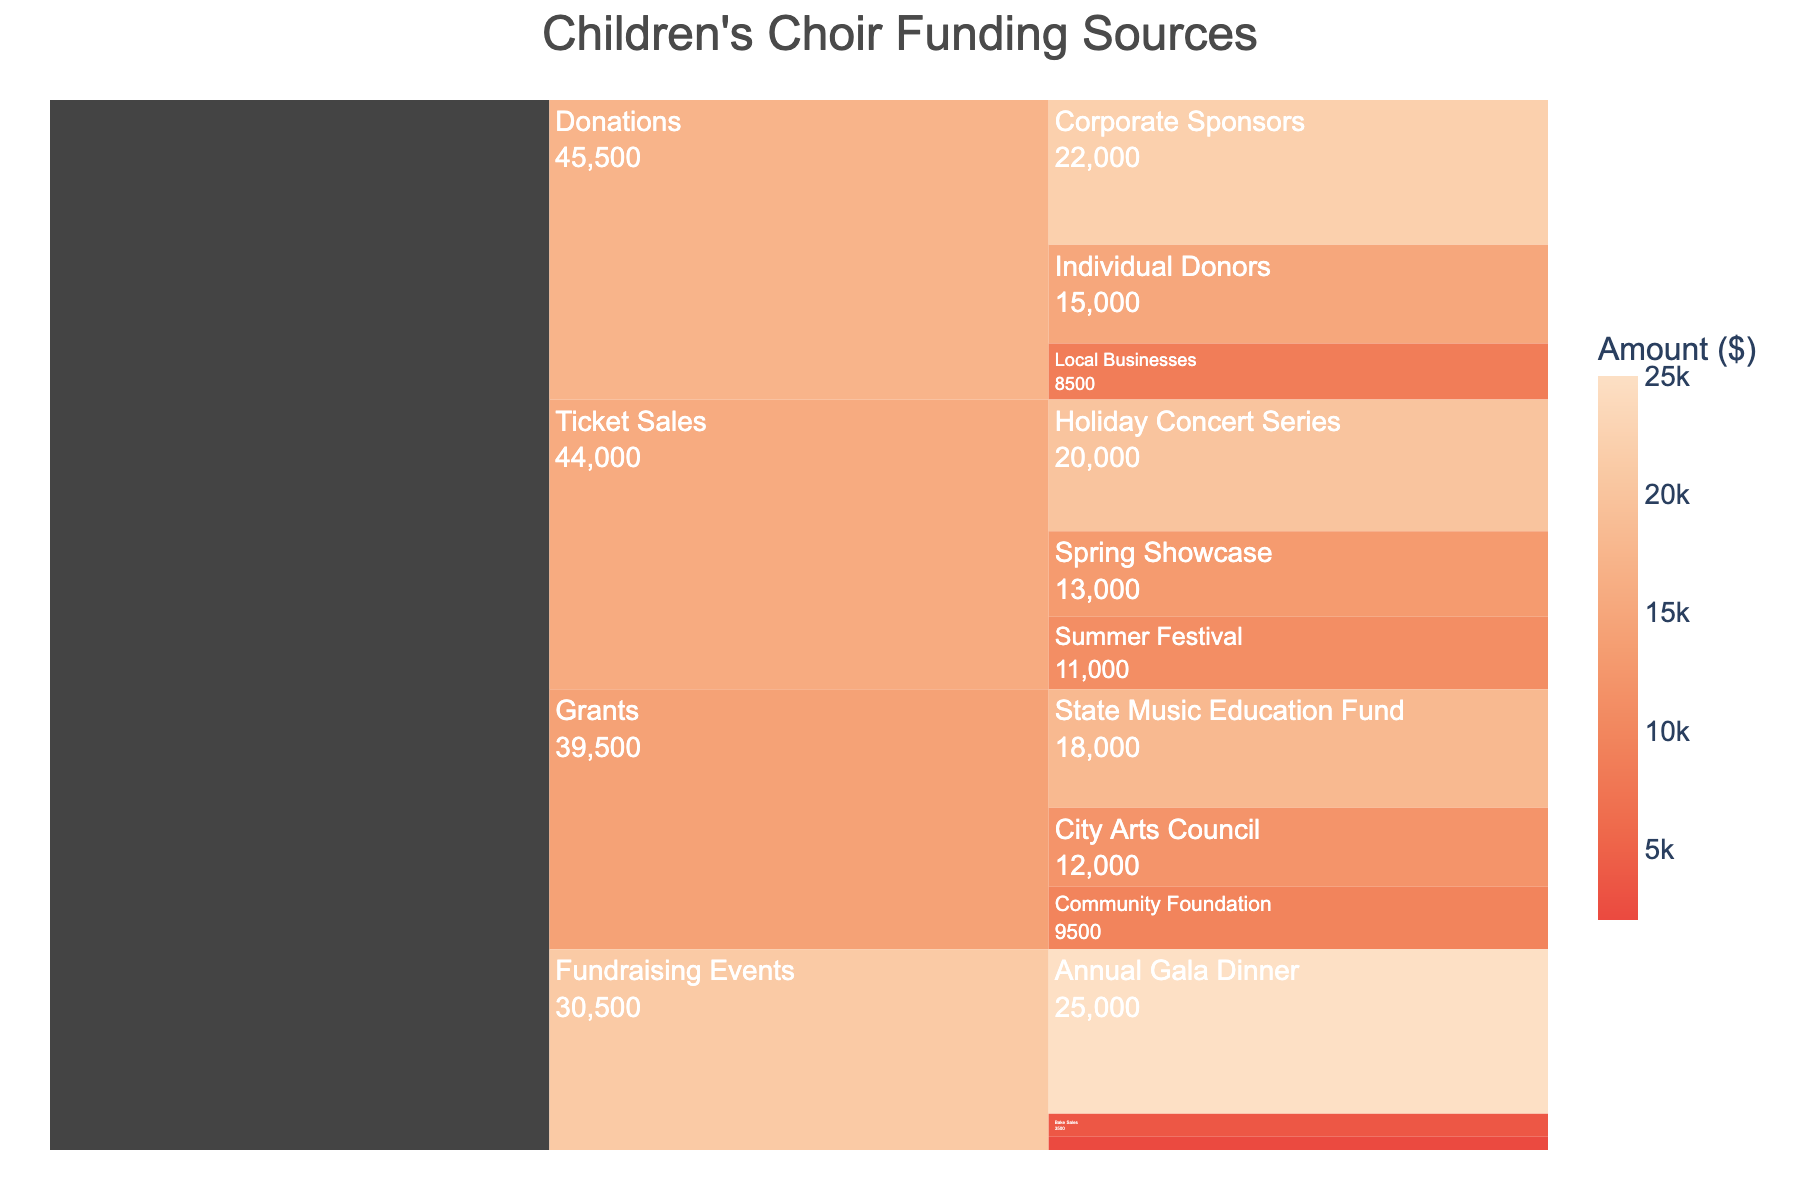What's the title of the chart? The title is usually displayed prominently at the top of a chart.
Answer: Children's Choir Funding Sources Which funding category has the highest total amount? To find the highest total amount, sum up the amounts for each category and compare them. The category with the highest total amount will be the answer.
Answer: Fundraising Events What is the total amount of funding from Donations? Add up the amounts from all the subcategories under Donations: 15000 (Individual Donors) + 22000 (Corporate Sponsors) + 8500 (Local Businesses).
Answer: 45500 What is the difference in the total amount between Ticket Sales and Grants? First, find the total for Ticket Sales (20000 + 13000 + 11000 = 44000) and for Grants (12000 + 18000 + 9500 = 39500). Then, subtract the total for Grants from Ticket Sales: 44000 - 39500.
Answer: 4500 Which subcategory under Fundraising Events contributes the most? By comparing the amounts in the subcategories under Fundraising Events, you can see which one has the highest value.
Answer: Annual Gala Dinner What is the color associated with the highest amount on the color scale? The highest amount is normally indicated by the color at the extreme end of the continuous color scale provided.
Answer: Dark Peach Which subcategory has the smallest amount? By identifying and comparing the amounts in all subcategories in the chart, the smallest value can be found.
Answer: Car Wash How much more funding does Individual Donors contribute compared to Local Businesses? Subtract the amount for Local Businesses from Individual Donors: 15000 - 8500.
Answer: 6500 How does the contribution from the City Arts Council compare to that from the State Music Education Fund? Compare the respective amounts for City Arts Council and State Music Education Fund directly.
Answer: State Music Education Fund contributes more What percentage of the total funding comes from Bake Sales? First, calculate the total funding by summing all amounts. Then, divide the amount for Bake Sales by the total funding and multiply by 100 to get the percentage. (3500 / 215500) * 100 = 1.62%.
Answer: 1.62% 